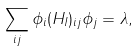Convert formula to latex. <formula><loc_0><loc_0><loc_500><loc_500>\sum _ { i j } \phi _ { i } ( H _ { I } ) _ { i j } \phi _ { j } = \lambda ,</formula> 